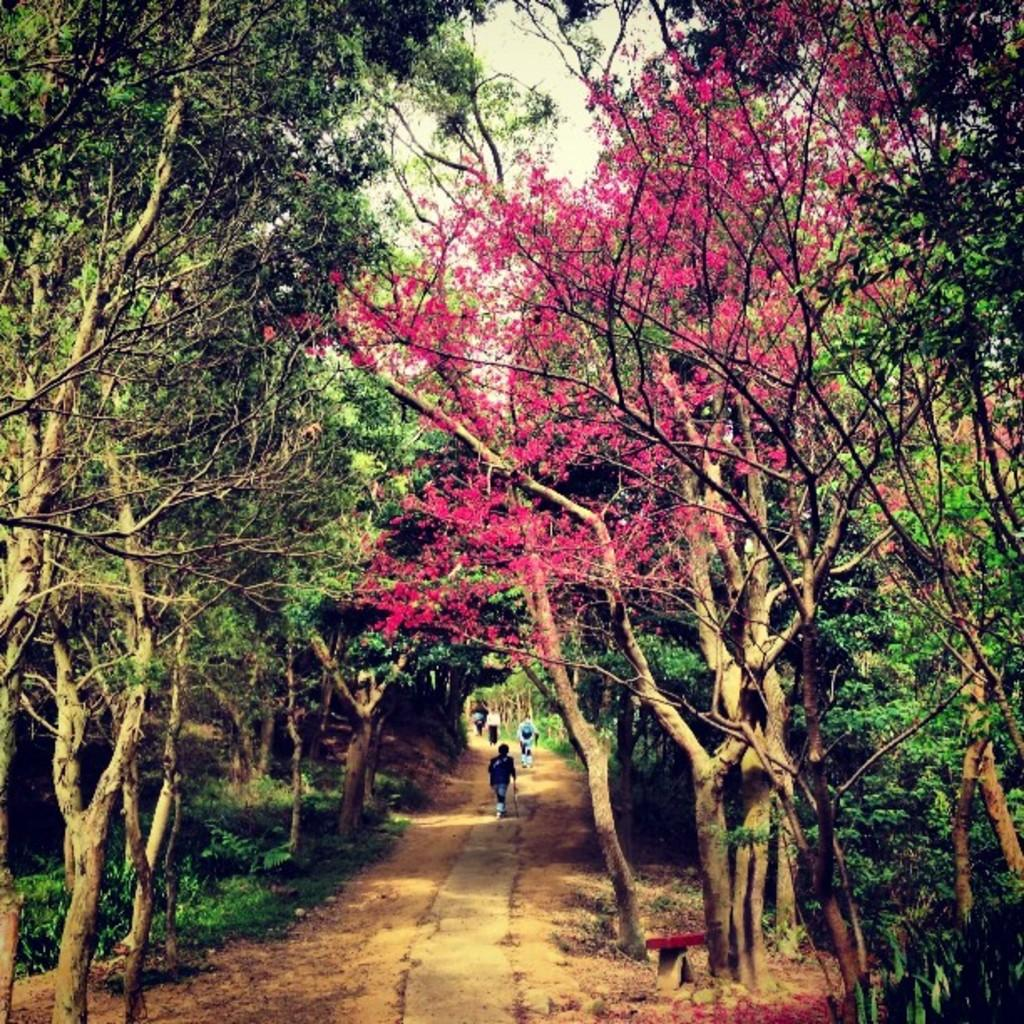What is happening with the group of people in the image? The people are walking in the image. What type of vegetation can be seen in the image? There are trees with pink flowers in the image. What is visible at the top of the image? The sky is visible at the top of the image. What is present at the bottom of the image? Grass is present at the bottom of the image. What beginner level is required to read the caption on the book in the image? There is no book or caption present in the image. 